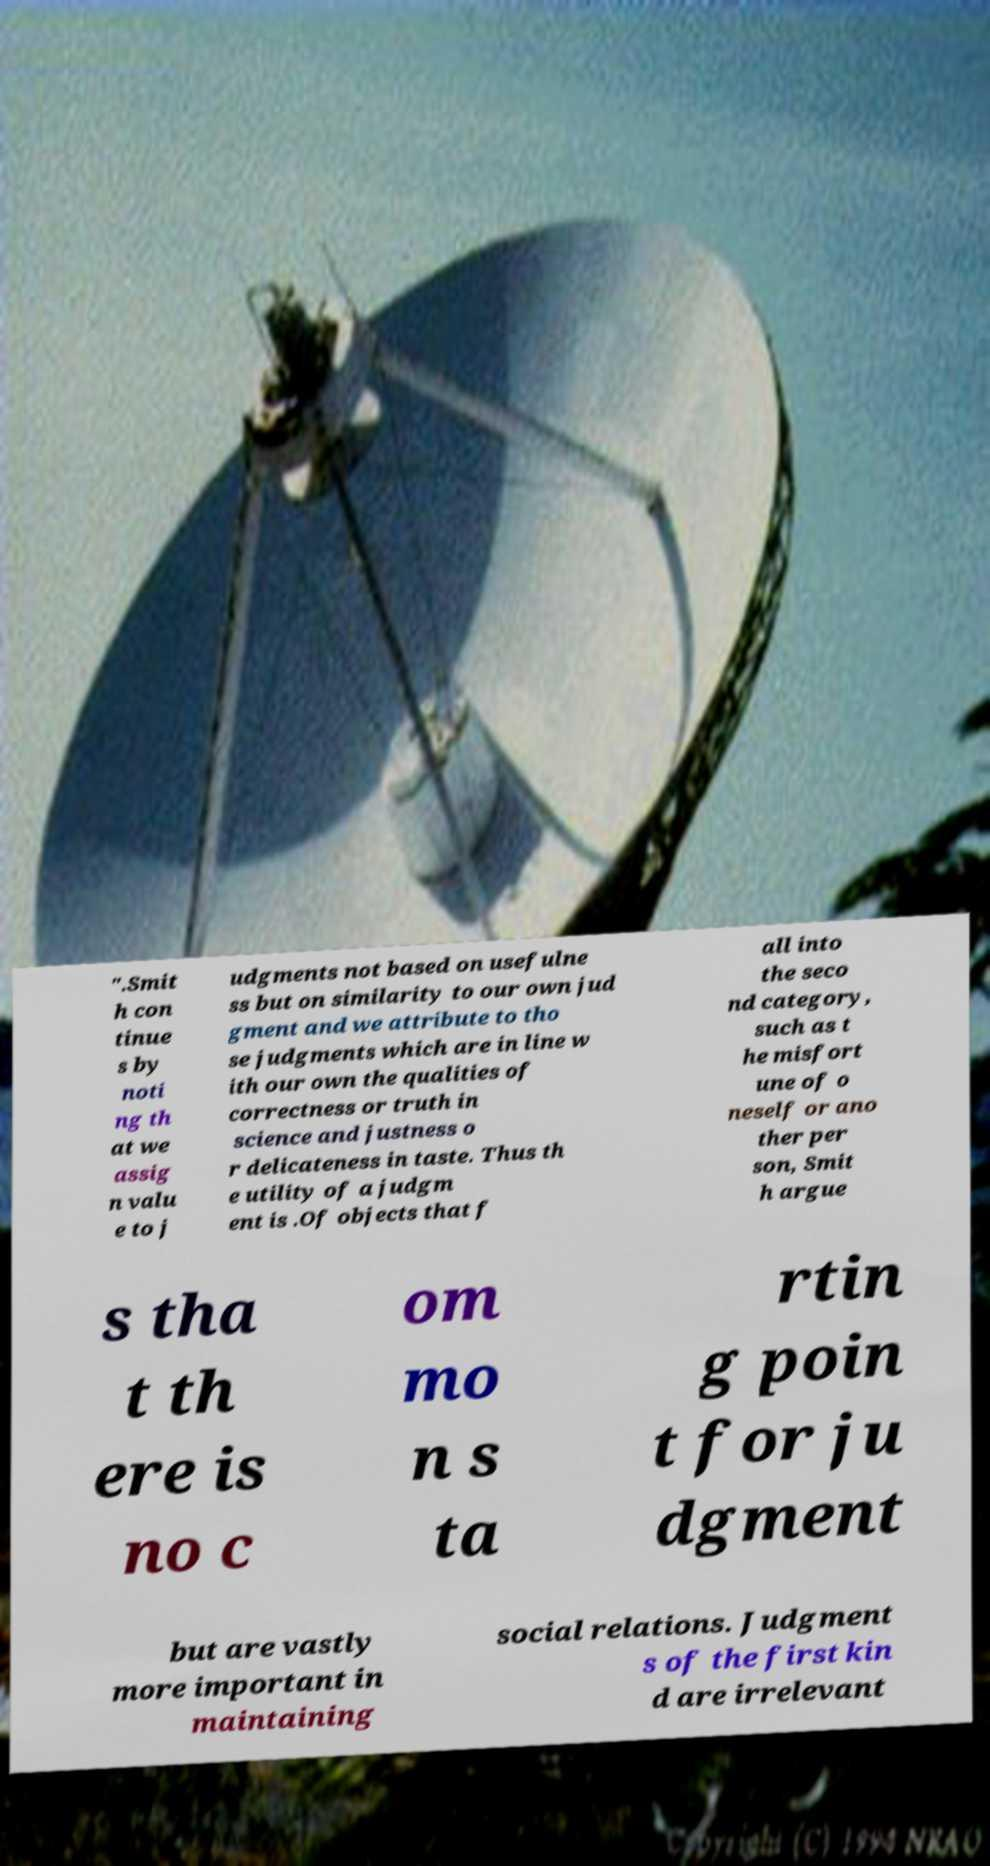For documentation purposes, I need the text within this image transcribed. Could you provide that? ".Smit h con tinue s by noti ng th at we assig n valu e to j udgments not based on usefulne ss but on similarity to our own jud gment and we attribute to tho se judgments which are in line w ith our own the qualities of correctness or truth in science and justness o r delicateness in taste. Thus th e utility of a judgm ent is .Of objects that f all into the seco nd category, such as t he misfort une of o neself or ano ther per son, Smit h argue s tha t th ere is no c om mo n s ta rtin g poin t for ju dgment but are vastly more important in maintaining social relations. Judgment s of the first kin d are irrelevant 